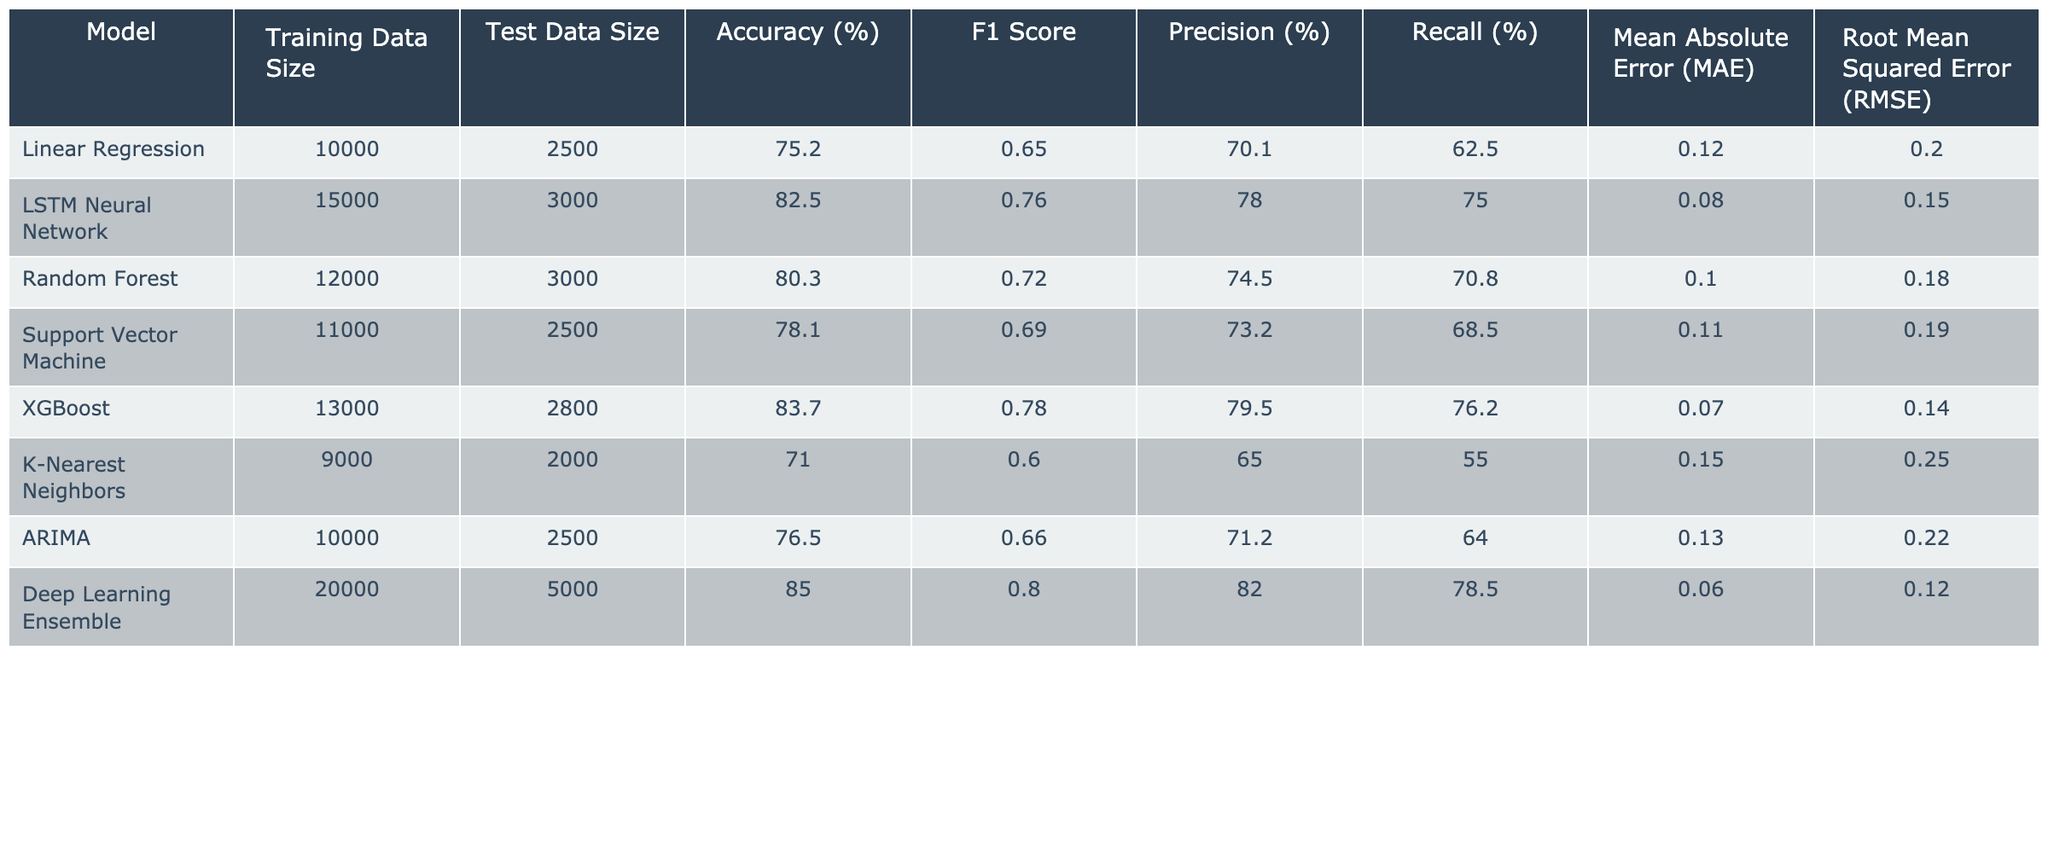What is the accuracy of the LSTM Neural Network model? The LSTM Neural Network model's accuracy is given in the table as 82.5%.
Answer: 82.5% Which model has the highest F1 Score? The F1 Score for each model can be compared, and the Deep Learning Ensemble model has the highest F1 Score of 0.80.
Answer: Deep Learning Ensemble What is the Mean Absolute Error of the XGBoost model? The Mean Absolute Error (MAE) for the XGBoost model is listed as 0.07 in the table.
Answer: 0.07 Which model has the lowest Precision, and what is its value? By reviewing the Precision values in the table, K-Nearest Neighbors has the lowest Precision at 65.0%.
Answer: K-Nearest Neighbors, 65.0% What is the recall of the Random Forest model? The recall value for the Random Forest model is provided in the table as 70.8%.
Answer: 70.8% What is the difference in accuracy between the Linear Regression and Random Forest models? The accuracy for Linear Regression is 75.2%, and for Random Forest, it is 80.3%. The difference is 80.3% - 75.2% = 5.1%.
Answer: 5.1% Which model uses the smallest Test Data Size? The K-Nearest Neighbors model uses a Test Data Size of 2000, the smallest among all models listed.
Answer: K-Nearest Neighbors What is the average Root Mean Squared Error (RMSE) of the models listed? To calculate the average RMSE, sum all RMSE values: 0.20 + 0.15 + 0.18 + 0.19 + 0.14 + 0.25 + 0.22 + 0.12 = 1.25. Then divide by the number of models (8): 1.25 / 8 = 0.15625.
Answer: 0.15625 Does the Support Vector Machine model have an accuracy greater than 75%? The Support Vector Machine model has an accuracy of 78.1%, which is indeed greater than 75%.
Answer: Yes Which model has the highest Precision, and what is the percentage? Comparing the Precision values, the Deep Learning Ensemble model has the highest Precision at 82.0%.
Answer: Deep Learning Ensemble, 82.0% 